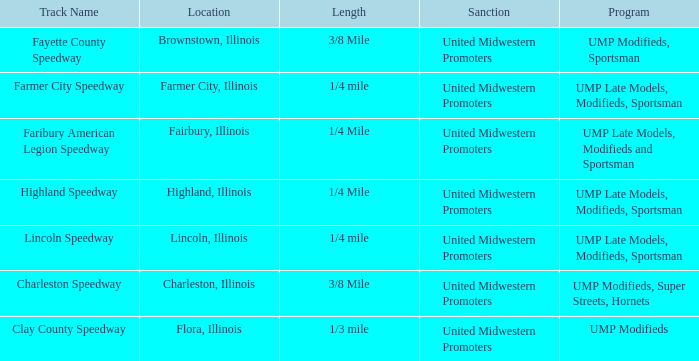Who sanctioned the event at fayette county speedway? United Midwestern Promoters. 